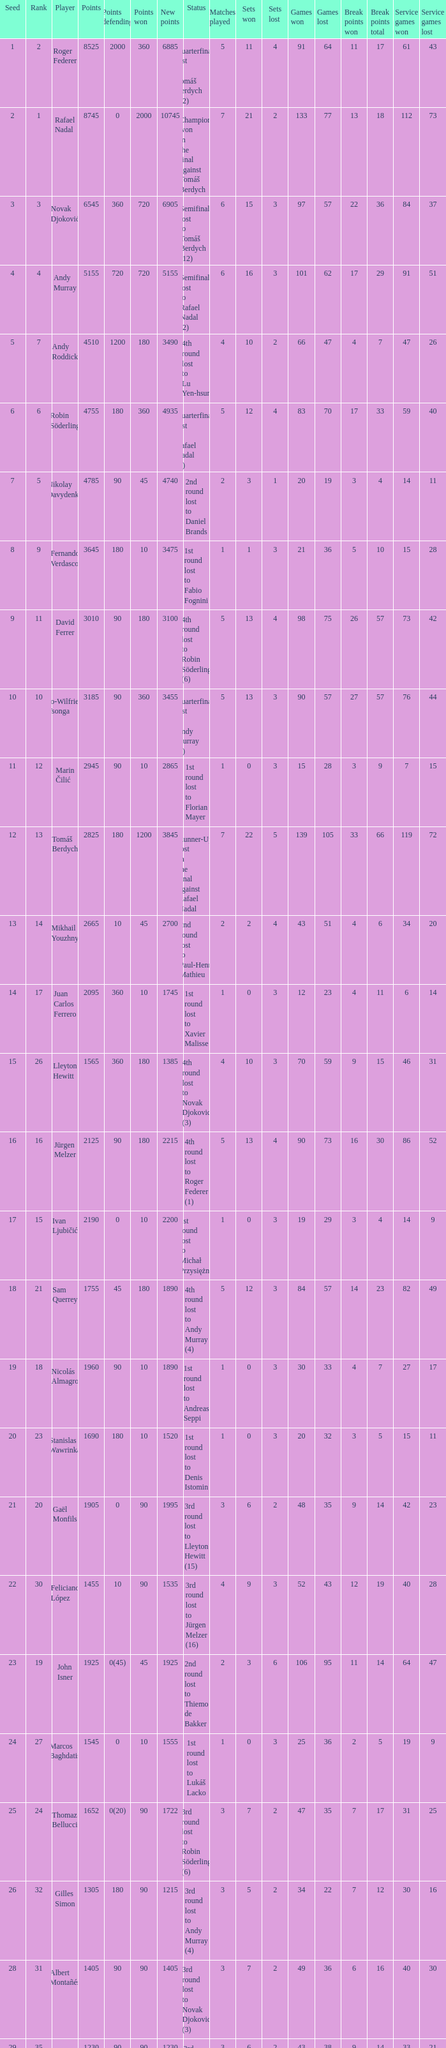Name the number of points defending for 1075 1.0. 